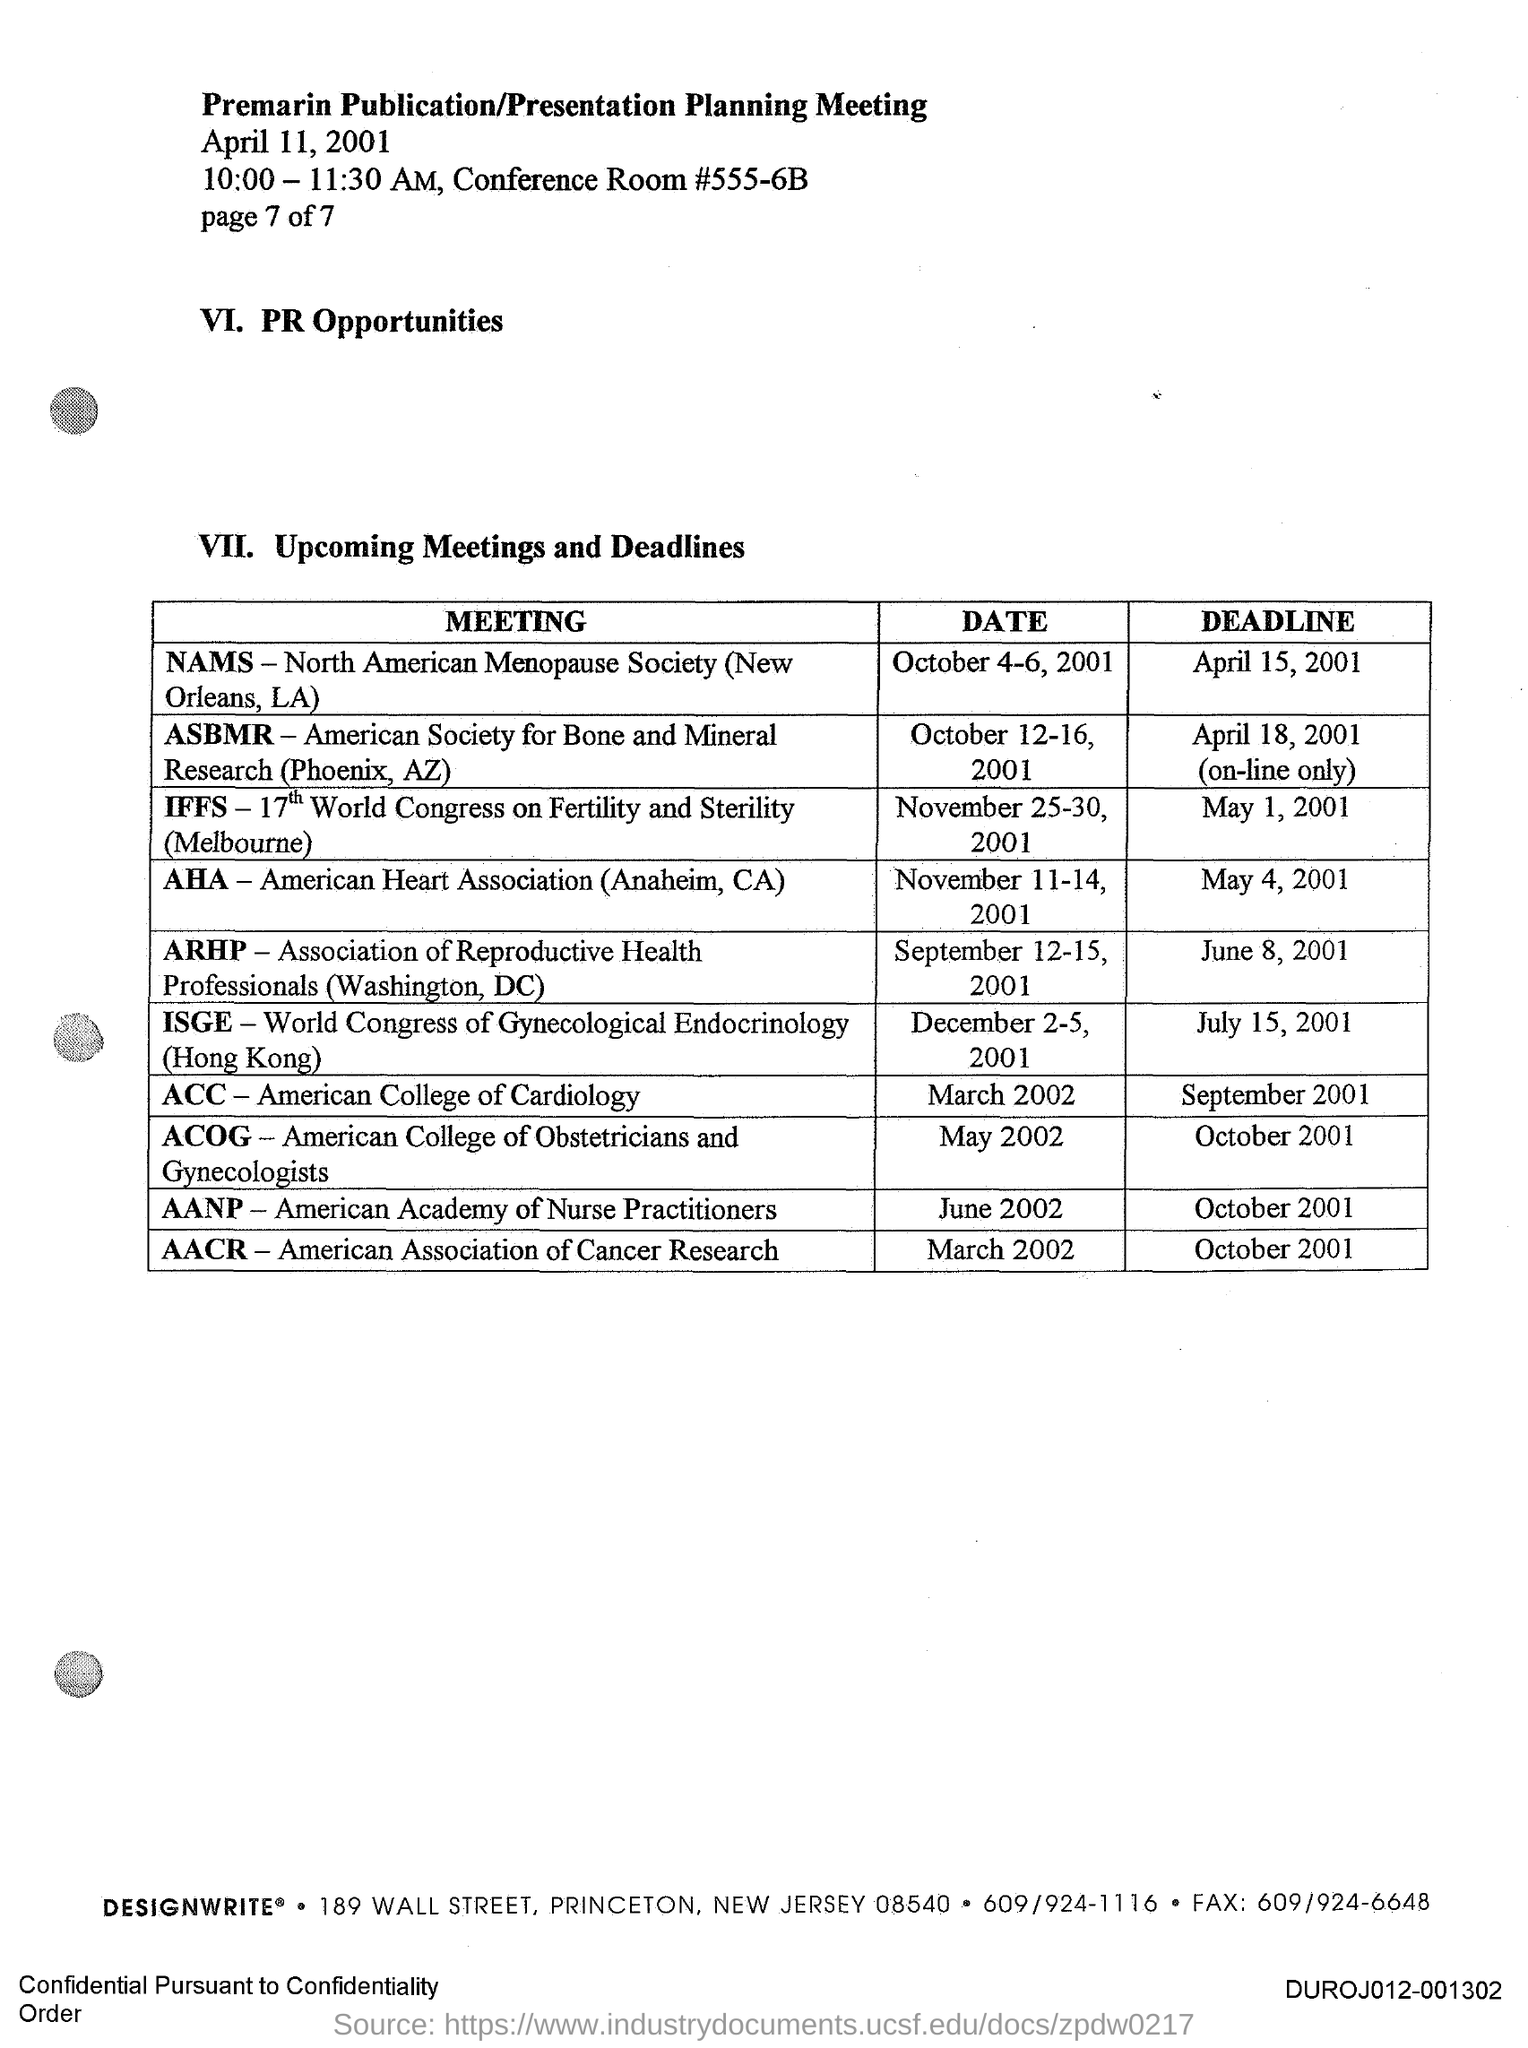Specify some key components in this picture. The deadline for the ARHP meeting is June 8, 2001. The deadline for the AANP meeting is October 2001. The deadline for the IFFS meeting is May 1, 2001. The deadline for the ACOG meeting is October 2001. The deadline for the ACC meeting is September 2001. 